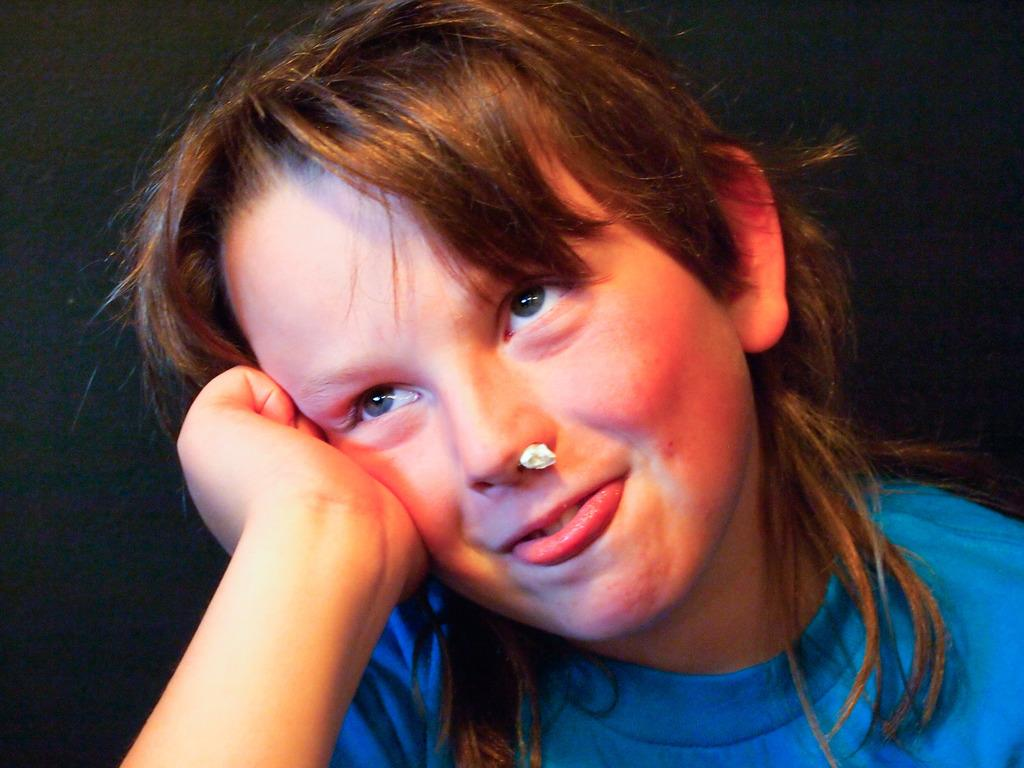Who or what is the main subject of the image? There is a person in the image. What is the person wearing? The person is wearing a blue t-shirt. Can you describe any unusual features of the person in the image? There is an object in the person's nose. What is the color of the background in the image? The background of the image is dark. What type of lead can be seen in the person's hand in the image? There is no lead visible in the person's hand in the image. What sign is the person holding in the image? There is no sign present in the image. 